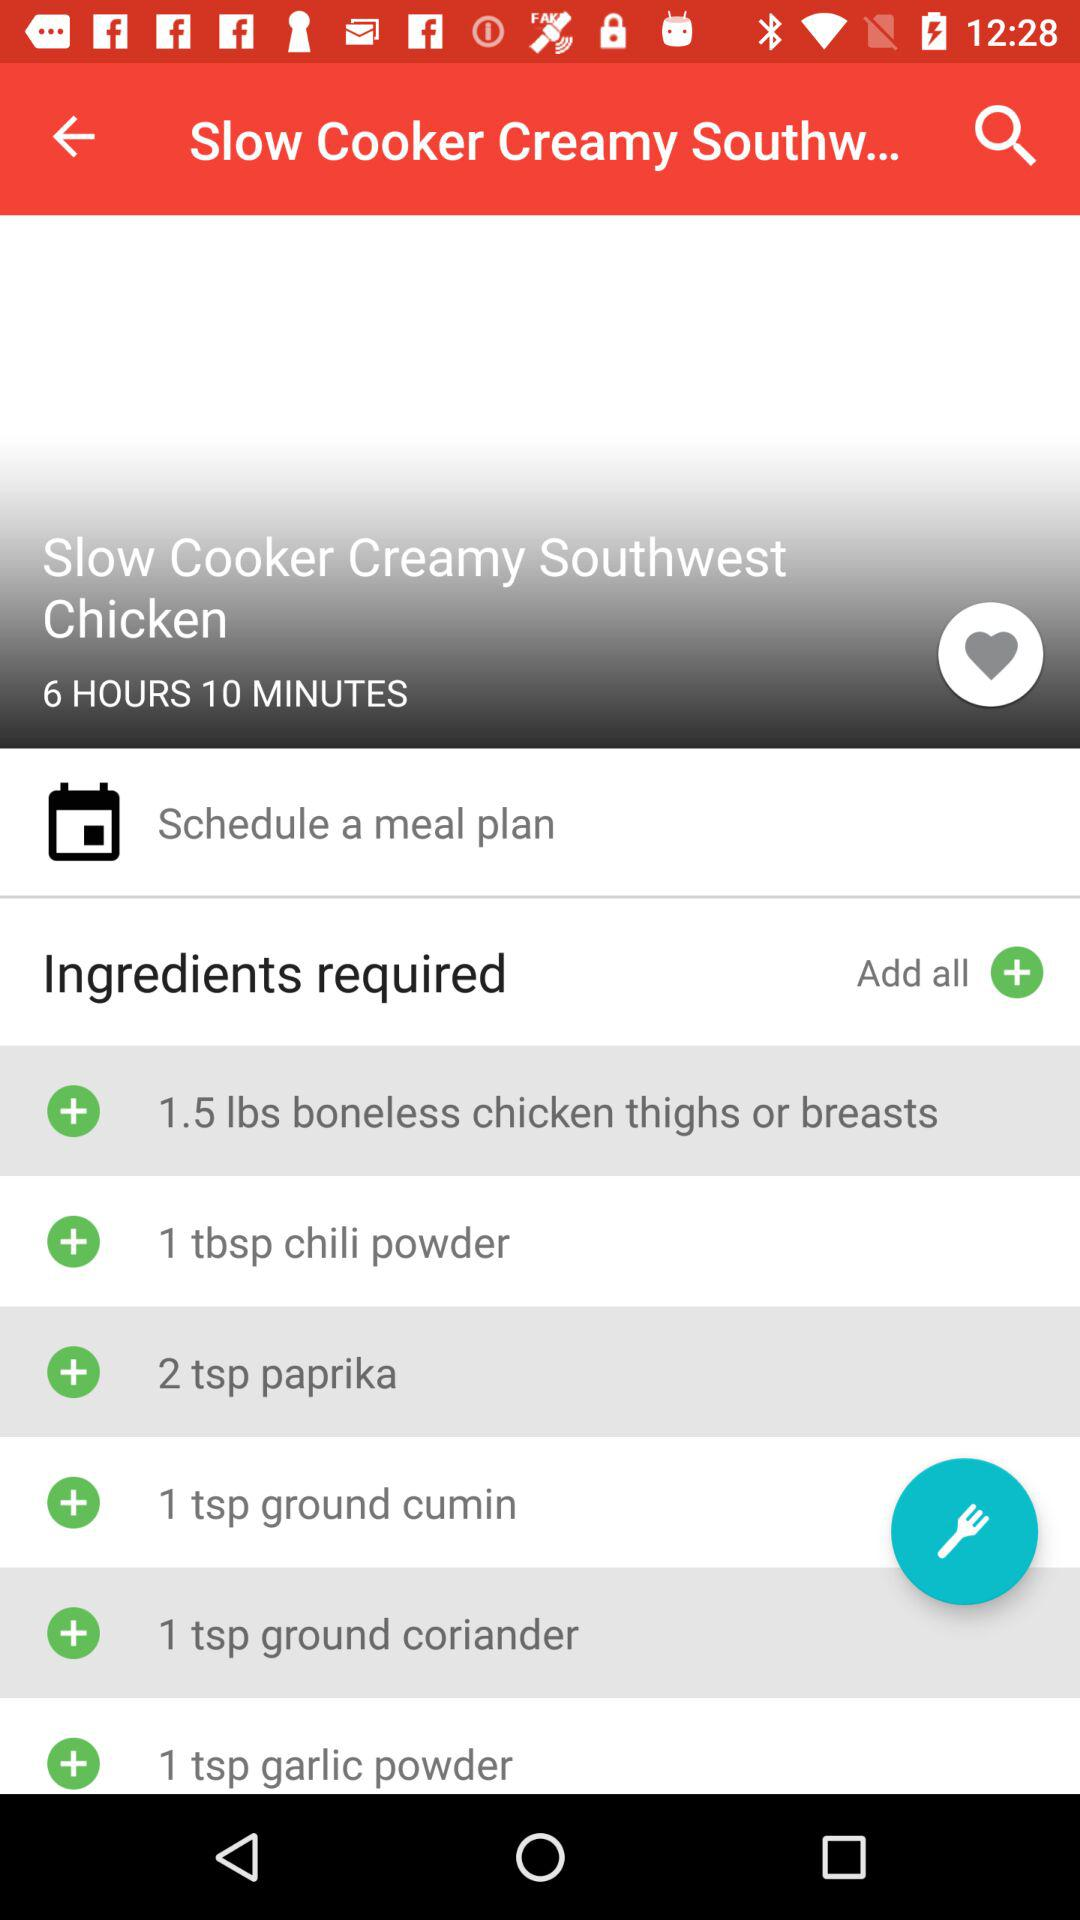How many tablespoons of chili powder are required? There is a need for 1 tablespoon of chili powder. 